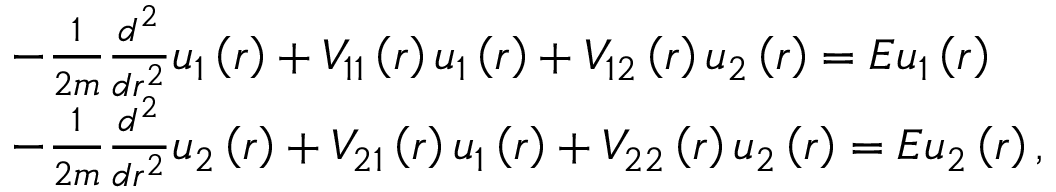<formula> <loc_0><loc_0><loc_500><loc_500>\begin{array} { r l } & { - \frac { 1 } { 2 m } \frac { d ^ { 2 } } { d r ^ { 2 } } u _ { 1 } \left ( r \right ) + V _ { 1 1 } \left ( r \right ) u _ { 1 } \left ( r \right ) + V _ { 1 2 } \left ( r \right ) u _ { 2 } \left ( r \right ) = E u _ { 1 } \left ( r \right ) } \\ & { - \frac { 1 } { 2 m } \frac { d ^ { 2 } } { d r ^ { 2 } } u _ { 2 } \left ( r \right ) + V _ { 2 1 } \left ( r \right ) u _ { 1 } \left ( r \right ) + V _ { 2 2 } \left ( r \right ) u _ { 2 } \left ( r \right ) = E u _ { 2 } \left ( r \right ) , } \end{array}</formula> 